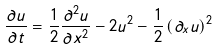<formula> <loc_0><loc_0><loc_500><loc_500>\frac { \partial u } { \partial t } = \frac { 1 } { 2 } \frac { \partial ^ { 2 } u } { \partial x ^ { 2 } } - 2 u ^ { 2 } - \frac { 1 } { 2 } \left ( \partial _ { x } u \right ) ^ { 2 }</formula> 